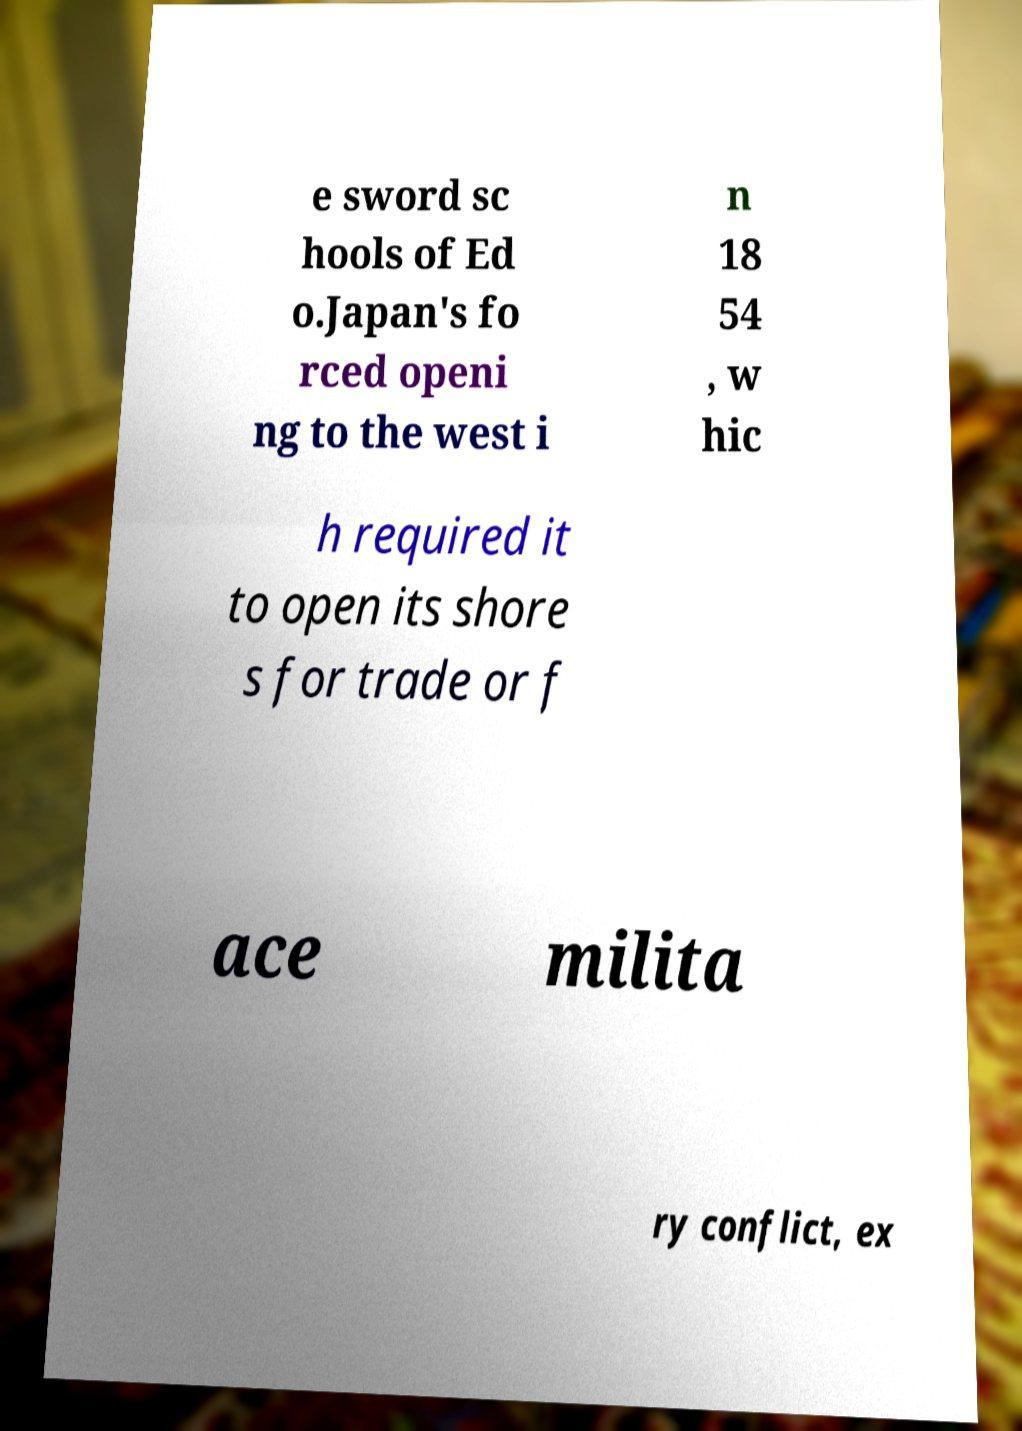For documentation purposes, I need the text within this image transcribed. Could you provide that? e sword sc hools of Ed o.Japan's fo rced openi ng to the west i n 18 54 , w hic h required it to open its shore s for trade or f ace milita ry conflict, ex 